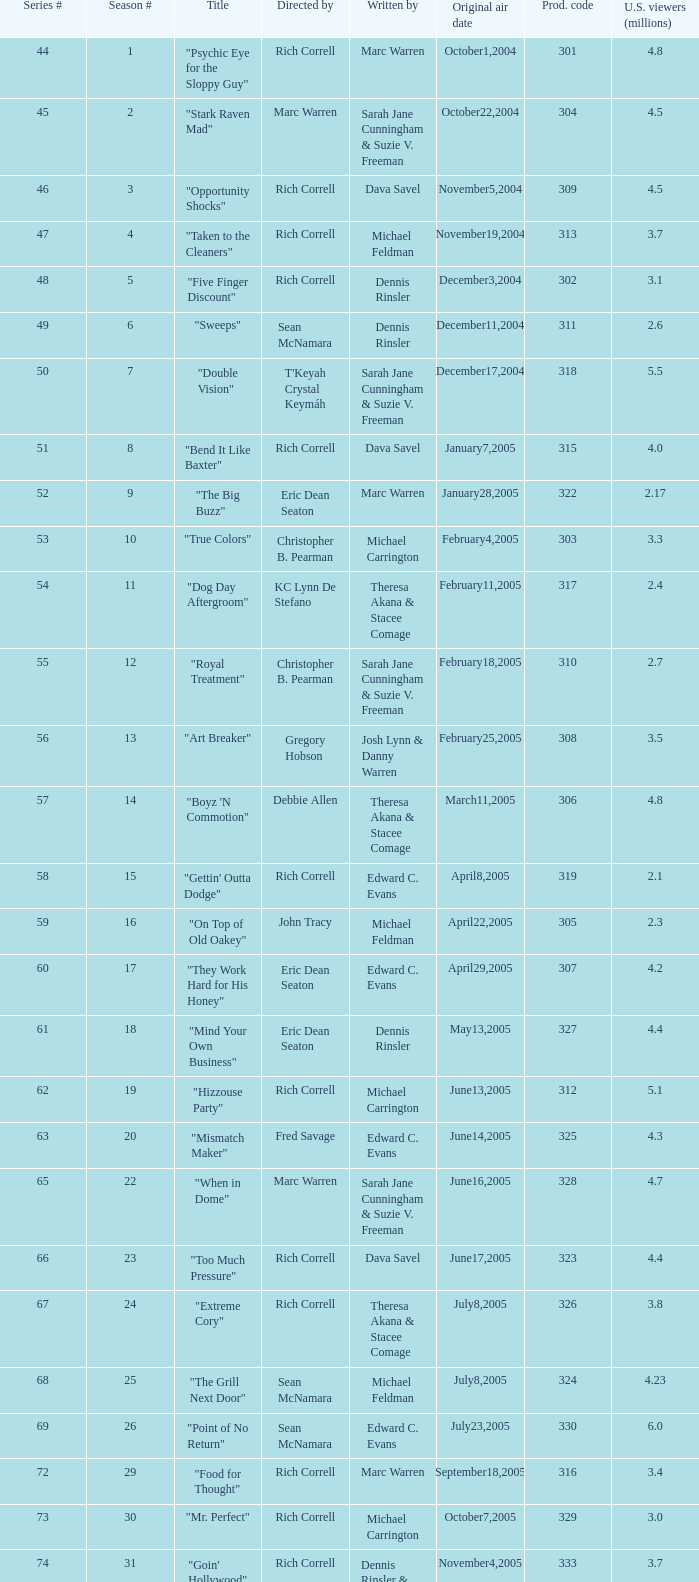Which episode number in the season had a production code of 334? 32.0. 